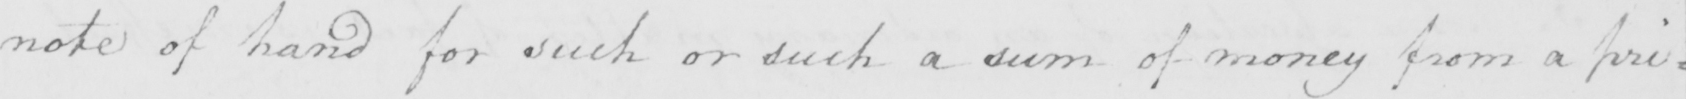Please provide the text content of this handwritten line. note of hand for such or such a sum of money from a pri= 